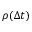<formula> <loc_0><loc_0><loc_500><loc_500>\rho ( \Delta t )</formula> 